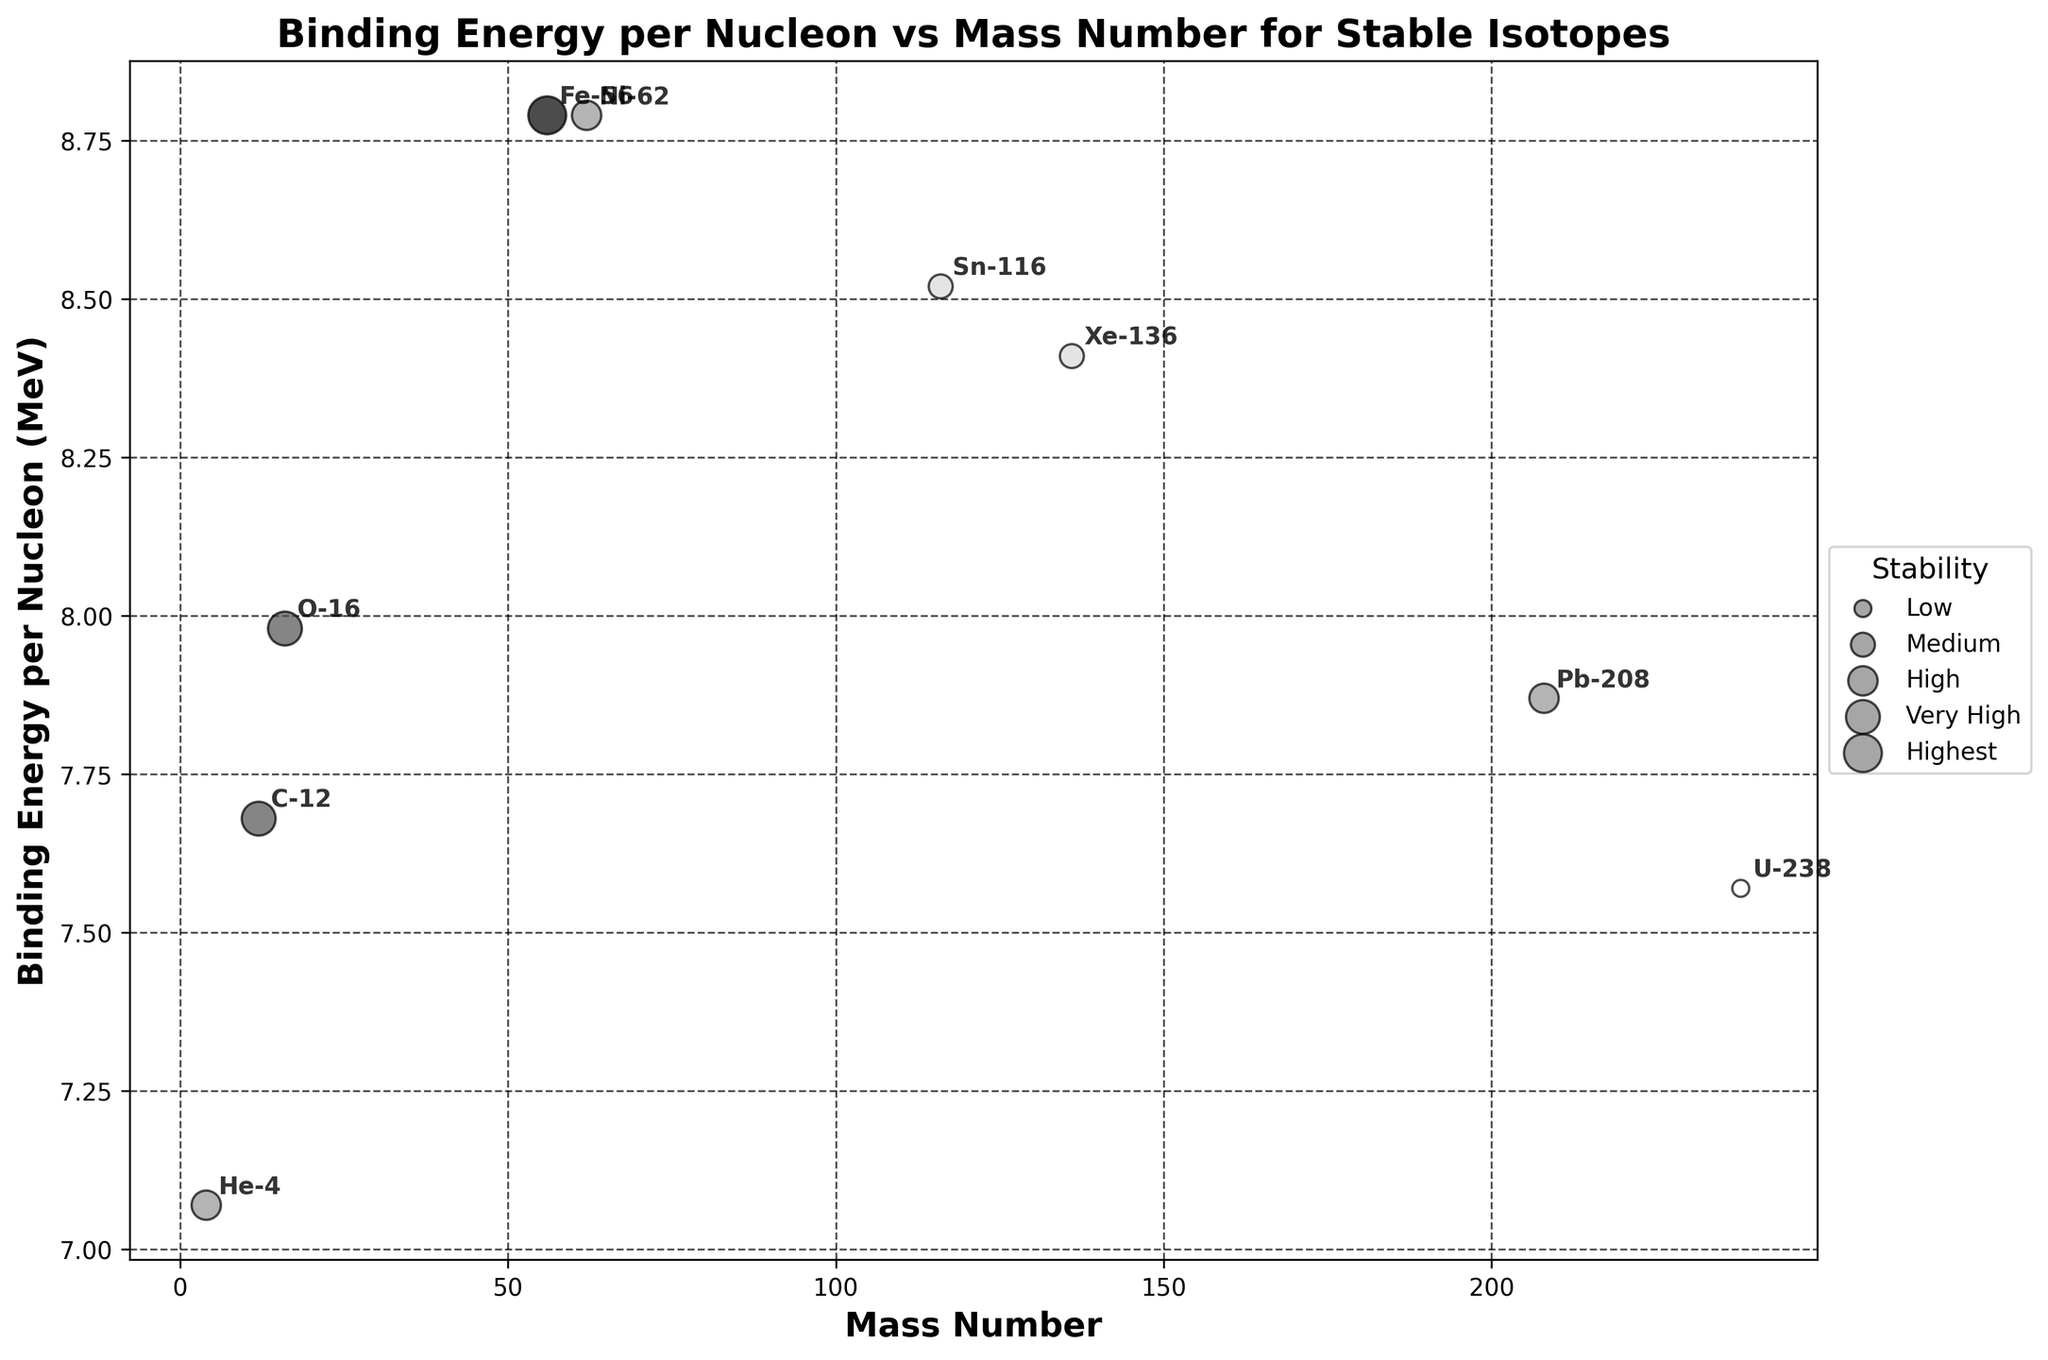What is the title of the plot? The title of the plot is displayed at the top of the figure.
Answer: Binding Energy per Nucleon vs Mass Number for Stable Isotopes Which isotope has the highest binding energy per nucleon? The isotope with the highest value on the y-axis (Binding Energy per Nucleon) in the plot is Fe-56.
Answer: Fe-56 What is the mass number of the isotope with the lowest binding energy per nucleon? The isotope with the lowest value on the y-axis (Binding Energy per Nucleon) in the plot is U-238, with a mass number of 238.
Answer: 238 How many isotopes are categorized under 'Very High' stability? By looking at the legend and scatter sizes that correspond to 'Very High' stability, we see two isotopes: C-12 and O-16.
Answer: 2 Compare the binding energy per nucleon between Ni-62 and Pb-208. Which one is higher? Refer to the y-axis values of Ni-62 (8.79) and Pb-208 (7.87); Ni-62 has a higher binding energy per nucleon.
Answer: Ni-62 What is the range of mass numbers among the isotopes displayed in the plot? The minimum mass number is 4 (He-4) and the maximum is 238 (U-238), so the range is 238 - 4.
Answer: 234 Which isotope has the highest stability and how is it represented in the plot? The isotope Fe-56 has the 'Highest' stability, indicated by the largest size circle according to the legend, and a color that is darker in the grayscale scheme.
Answer: Fe-56 Calculate the average binding energy per nucleon for isotopes with 'Medium' stability. The isotopes' values are Sn-116 (8.52) and Xe-136 (8.41). The average is (8.52 + 8.41) / 2.
Answer: 8.465 What pattern can be observed between mass number and binding energy per nucleon? Most of the isotopes' binding energy per nucleon increases and reaches a peak around mass numbers 56-62, then gradually decreases.
Answer: Increases then decreases 